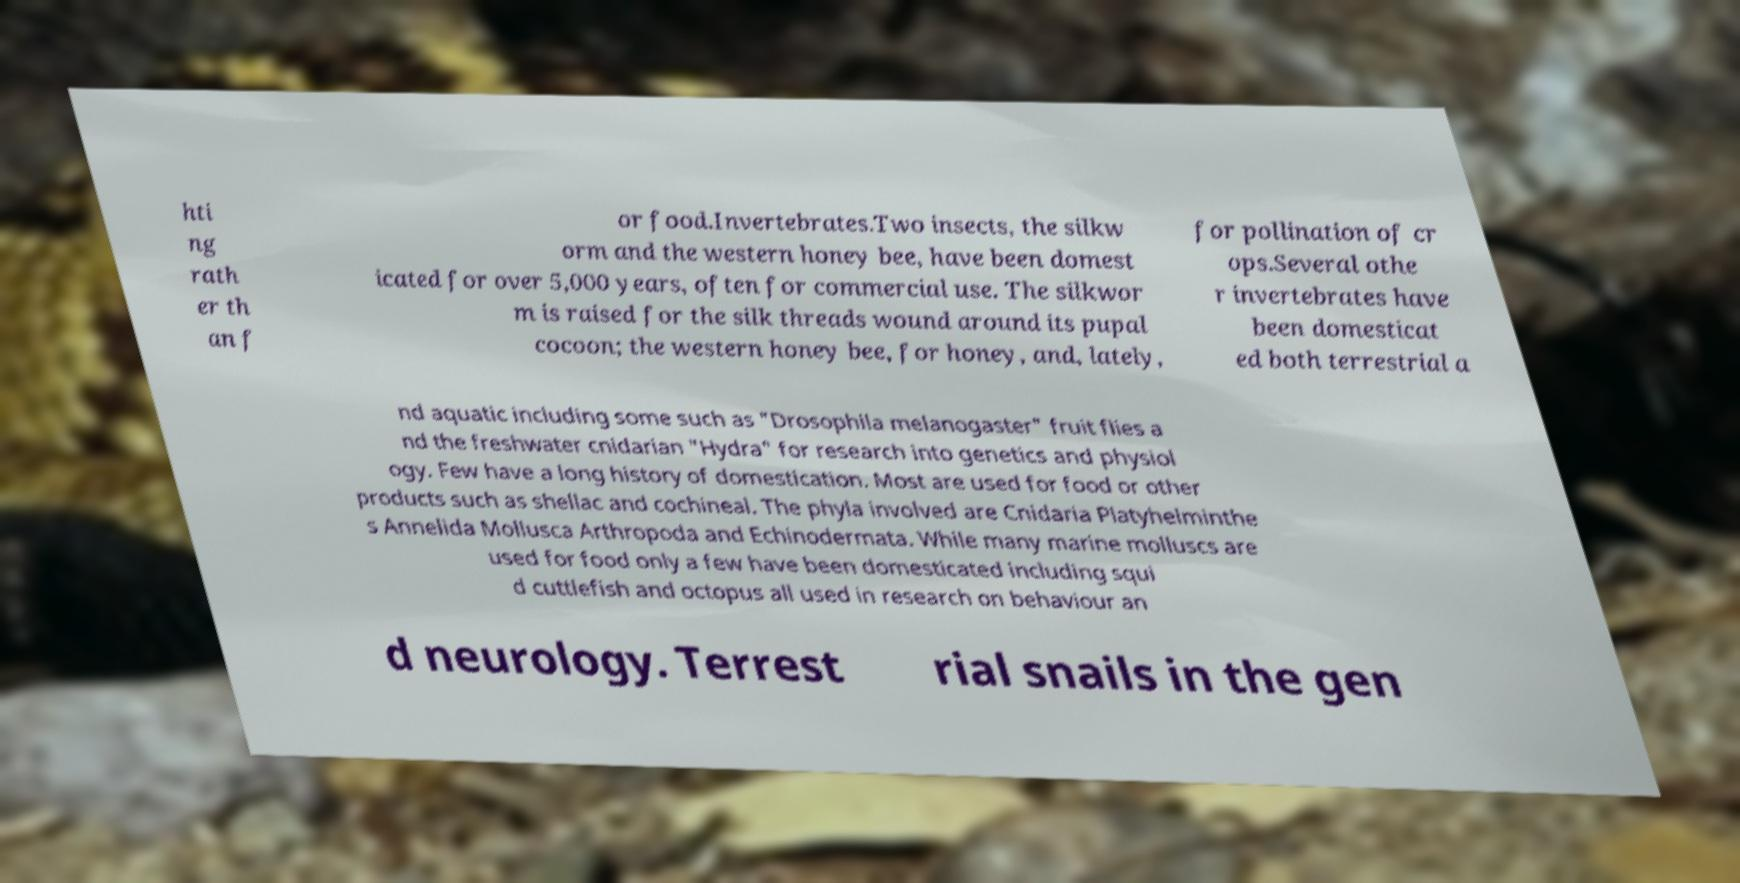I need the written content from this picture converted into text. Can you do that? hti ng rath er th an f or food.Invertebrates.Two insects, the silkw orm and the western honey bee, have been domest icated for over 5,000 years, often for commercial use. The silkwor m is raised for the silk threads wound around its pupal cocoon; the western honey bee, for honey, and, lately, for pollination of cr ops.Several othe r invertebrates have been domesticat ed both terrestrial a nd aquatic including some such as "Drosophila melanogaster" fruit flies a nd the freshwater cnidarian "Hydra" for research into genetics and physiol ogy. Few have a long history of domestication. Most are used for food or other products such as shellac and cochineal. The phyla involved are Cnidaria Platyhelminthe s Annelida Mollusca Arthropoda and Echinodermata. While many marine molluscs are used for food only a few have been domesticated including squi d cuttlefish and octopus all used in research on behaviour an d neurology. Terrest rial snails in the gen 